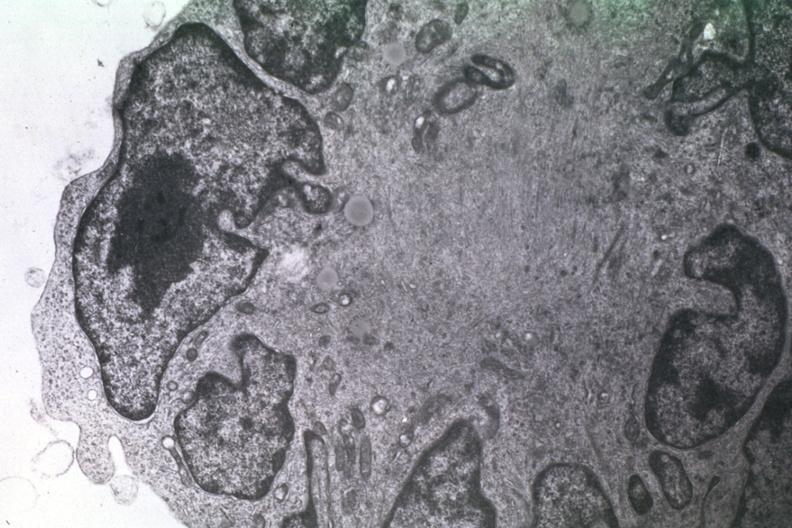what does this image show?
Answer the question using a single word or phrase. Dr garcia tumors 24 